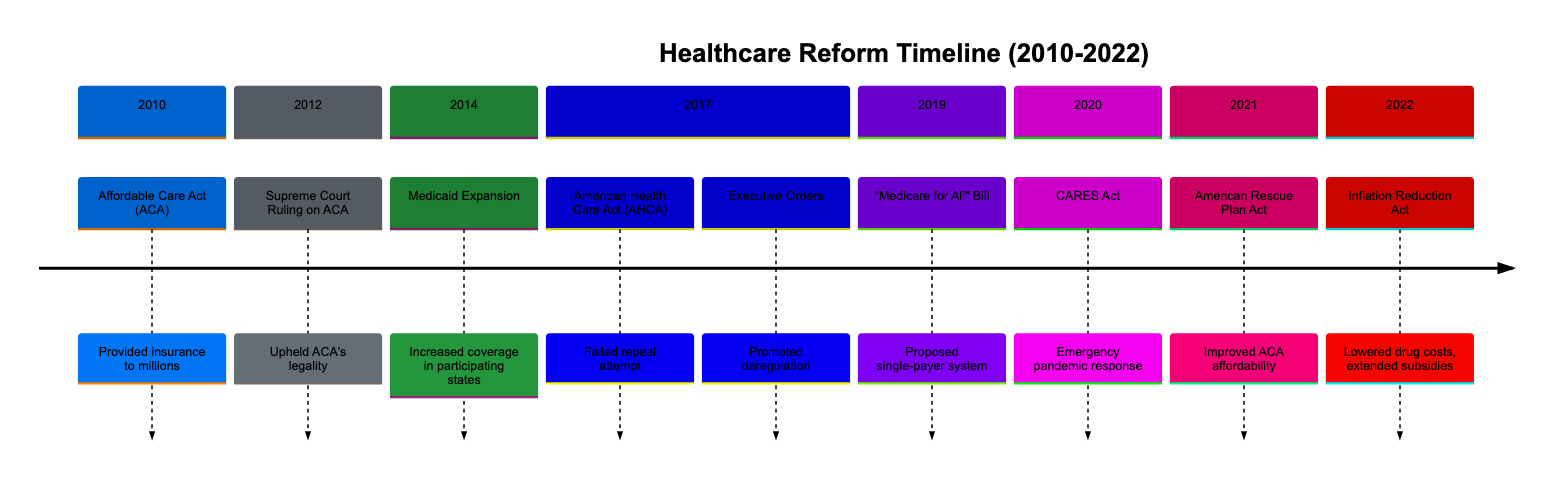What major healthcare reform was enacted in 2010? The diagram indicates that the Affordable Care Act (ACA) was signed into law in 2010. This is denoted clearly in the timeline section.
Answer: Affordable Care Act (ACA) How many major events are shown in the timeline for the year 2017? Looking at the timeline for 2017, there are two notable entries: the American Health Care Act and Executive Orders. Therefore, there are two events.
Answer: 2 What was the main outcome of the Supreme Court Ruling on ACA in 2012? The timeline specifies that the Supreme Court upheld the legality of the ACA, which directly clarifies its significant outcome in relation to healthcare law.
Answer: Upheld ACA's legality Which act significantly addressed pandemic response in 2020? According to the timeline, the CARES Act is highlighted as the key legislation aimed at emergency pandemic response during the year 2020.
Answer: CARES Act What year did the “Medicare for All” bill get introduced? The timeline indicates that the introduction of the “Medicare for All” bill took place in 2019. This can be verified easily by checking that year's section.
Answer: 2019 Which act included provisions to lower prescription drug costs in 2022? The timeline shows that the Inflation Reduction Act includes specific healthcare provisions aimed at lowering prescription drug costs, making it the focused legislation for that year.
Answer: Inflation Reduction Act What was the main impact of the American Rescue Plan Act in 2021? The timeline details that this act improved healthcare affordability and access, thus indicating its intended and significant impact on healthcare during that year.
Answer: Improved healthcare affordability How many sections are dedicated to healthcare reforms introduced after 2017? By examining the timeline, we note that there are three sections labeled for 2019, 2020, 2021, and 2022, which count to four meaningful entries post-2017.
Answer: 4 